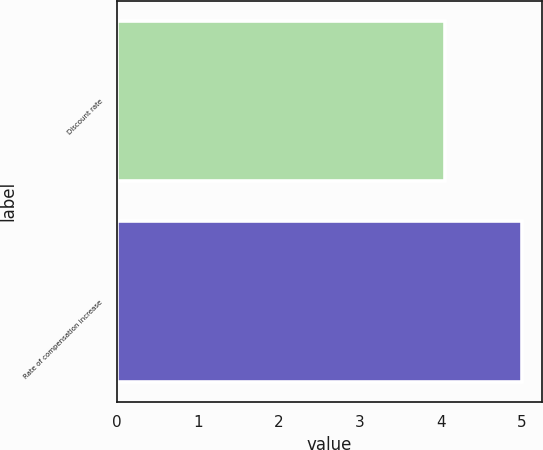Convert chart to OTSL. <chart><loc_0><loc_0><loc_500><loc_500><bar_chart><fcel>Discount rate<fcel>Rate of compensation increase<nl><fcel>4.05<fcel>5<nl></chart> 